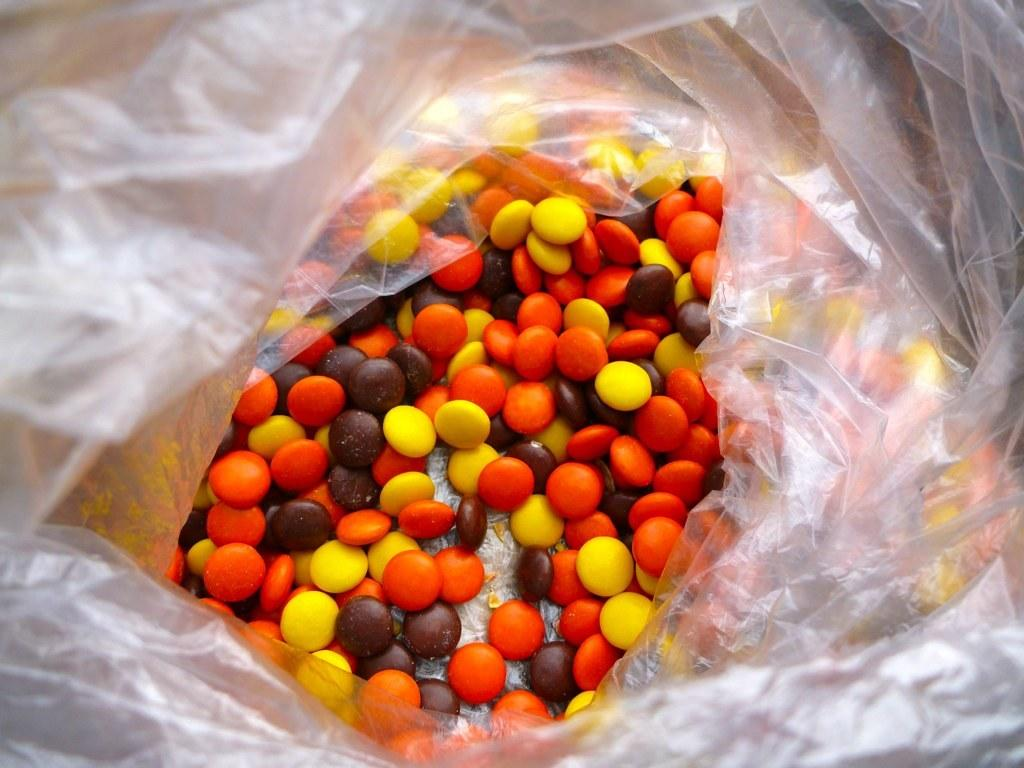What is present in the plastic cover in the image? There are germs in the plastic cover. How many times do the germs jump in the image? There is no indication of the germs jumping in the image, as they are likely stationary within the plastic cover. 